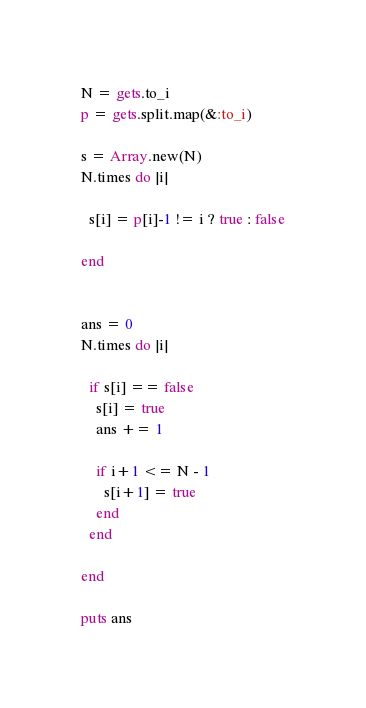Convert code to text. <code><loc_0><loc_0><loc_500><loc_500><_Ruby_>N = gets.to_i
p = gets.split.map(&:to_i)

s = Array.new(N)
N.times do |i|
  
  s[i] = p[i]-1 != i ? true : false
  
end


ans = 0
N.times do |i|
  
  if s[i] == false
    s[i] = true
    ans += 1
    
    if i+1 <= N - 1 
      s[i+1] = true
    end
  end
      
end

puts ans</code> 